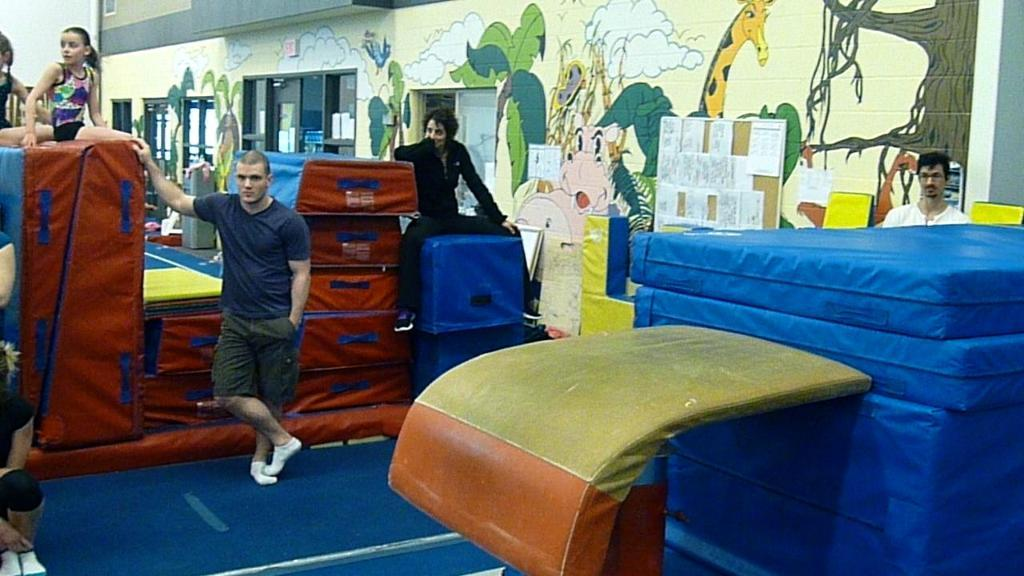Who or what can be seen in the image? There are people in the image. What is the appearance of the walls in the image? The walls in the image are painted. What architectural feature is present in the image? There are windows in the image. What type of containers are visible in the image? Cardboard cartons are present in the image. How many times does the person in the image bend their knee? There is no specific person mentioned in the image, and no action of bending a knee is depicted. 